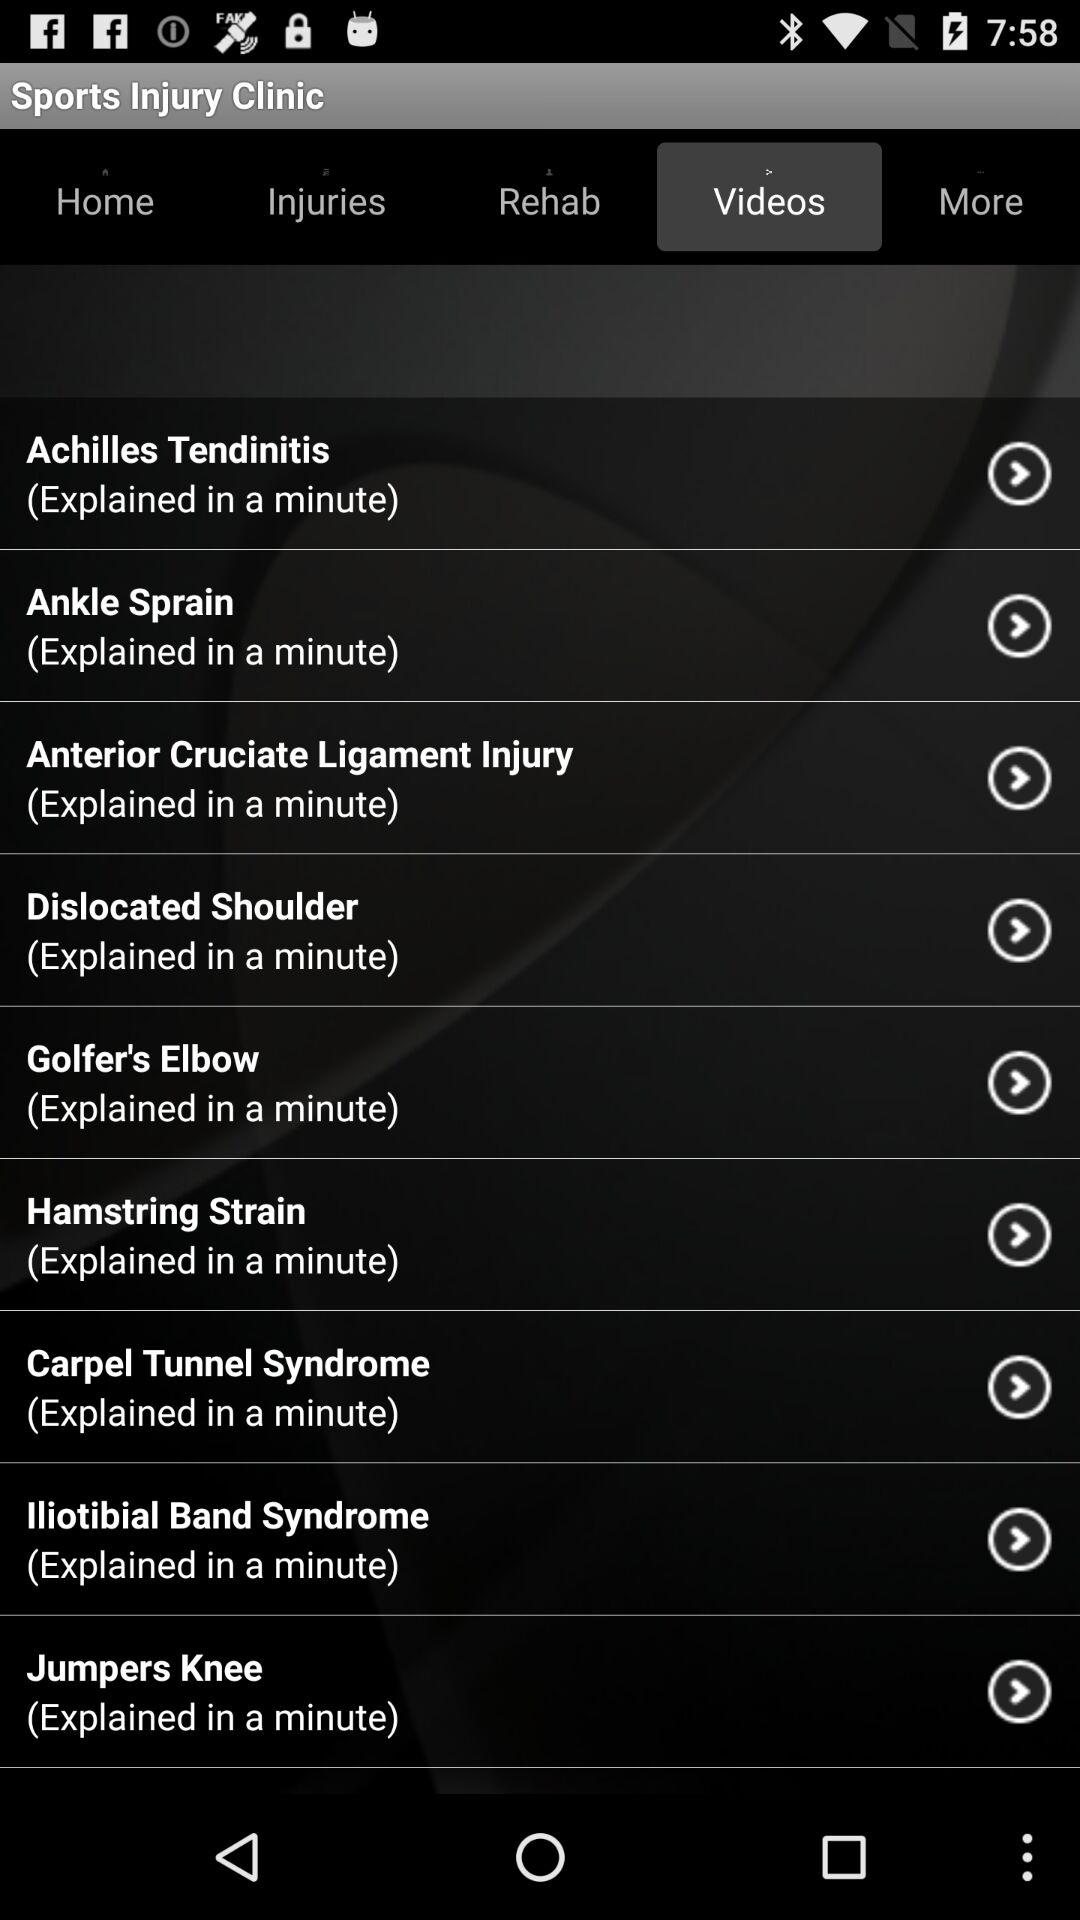What is the name of the application? The name of the application is "Sports Injury Clinic". 